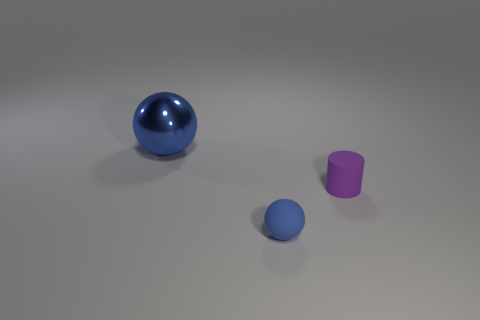Add 2 blue blocks. How many objects exist? 5 Add 2 tiny rubber cylinders. How many tiny rubber cylinders are left? 3 Add 3 cylinders. How many cylinders exist? 4 Subtract 0 red spheres. How many objects are left? 3 Subtract all spheres. How many objects are left? 1 Subtract all purple cylinders. Subtract all large shiny things. How many objects are left? 1 